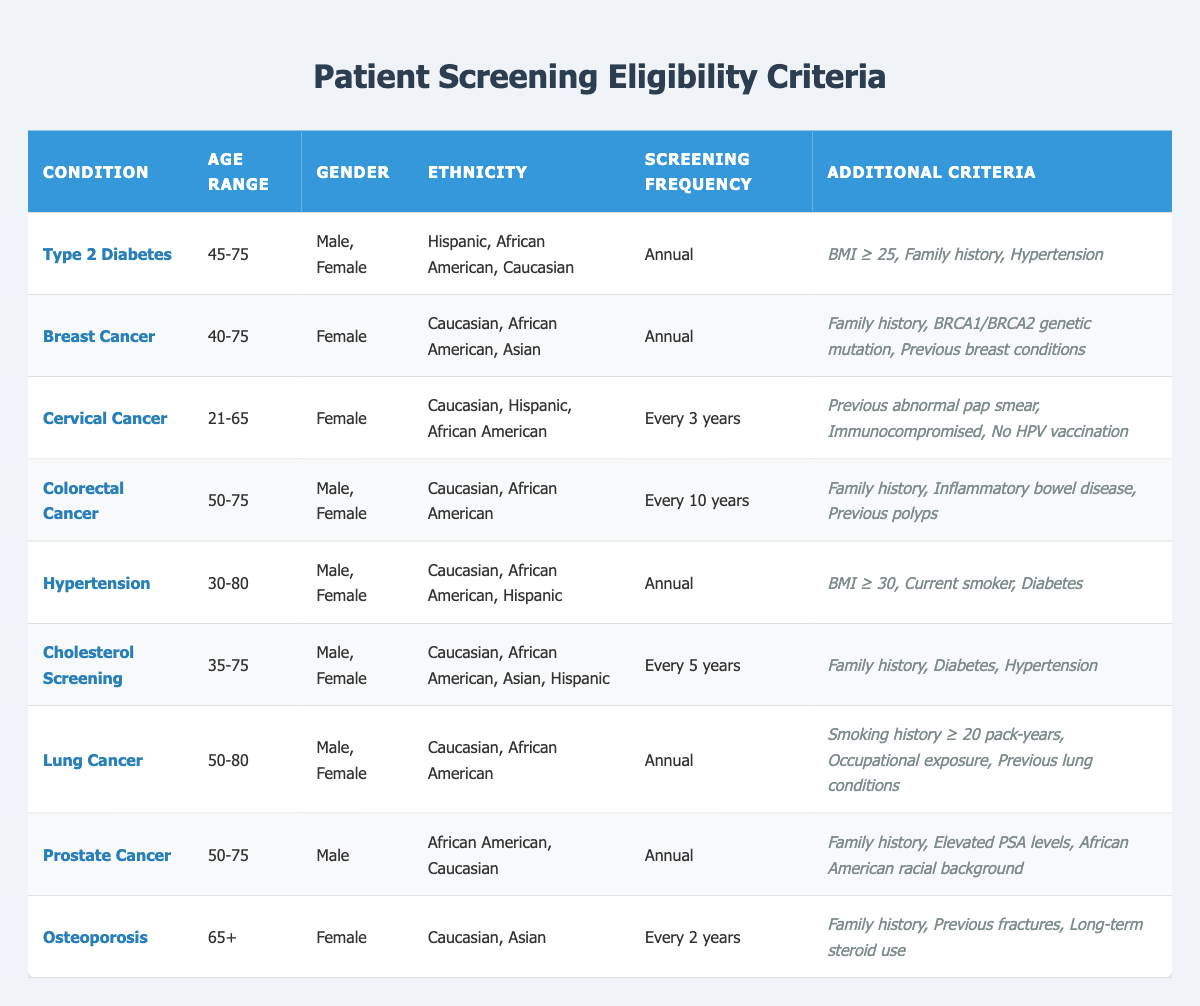What is the age range for Cervical Cancer screening? The table indicates that the age range for Cervical Cancer screening is "21-65". This information is directly obtained from the row pertaining to Cervical Cancer in the table.
Answer: 21-65 Are males eligible for Breast Cancer screening? The table specifically states that the gender eligible for Breast Cancer screening is "Female". Therefore, males are not eligible based on this criteria.
Answer: No What is the screening frequency for Prostate Cancer? According to the table, the screening frequency for Prostate Cancer is "Annual". This is directly taken from the relevant row in the table that lists Prostate Cancer.
Answer: Annual How many years between screenings for Colorectal Cancer? The table specifies that Colorectal Cancer screening should occur "Every 10 years". This detail is found in the corresponding row for Colorectal Cancer.
Answer: Every 10 years Do individuals with a family history need to screen for Hypertension? The additional criteria for Hypertension do not include a family history requirement. However, they mention that the individual must have a BMI ≥ 30, be a current smoker, and have diabetes. Thus, a family history is not necessary for screening.
Answer: No What proportion of conditions listed have a screening frequency of Annual? From the table, the conditions with an Annual screening frequency are Type 2 Diabetes, Breast Cancer, Hypertension, Lung Cancer, and Prostate Cancer, which totals 5 out of 9 conditions listed. To calculate the proportion, divide 5 by 9, resulting in approximately 0.56.
Answer: Approximately 0.56 Which conditions require both a previous abnormal pap smear and being immunocompromised? The table shows that the condition requiring both a previous abnormal pap smear and being immunocompromised is "Cervical Cancer". This can be confirmed by reviewing the additional criteria listed for Cervical Cancer in the table.
Answer: Cervical Cancer Is it true that Colorectal Cancer screening is required every 3 years? The table clearly states that Colorectal Cancer screening occurs "Every 10 years", not every 3 years. Therefore, the assertion that it is every 3 years is false.
Answer: No What is the additional eligibility criterion for Cholesterol Screening related to hypertension? The table states that for Cholesterol Screening, one of the additional criteria is "Hypertension: Yes". This means that having hypertension is an additional eligibility criterion for this screening.
Answer: Hypertension: Yes 